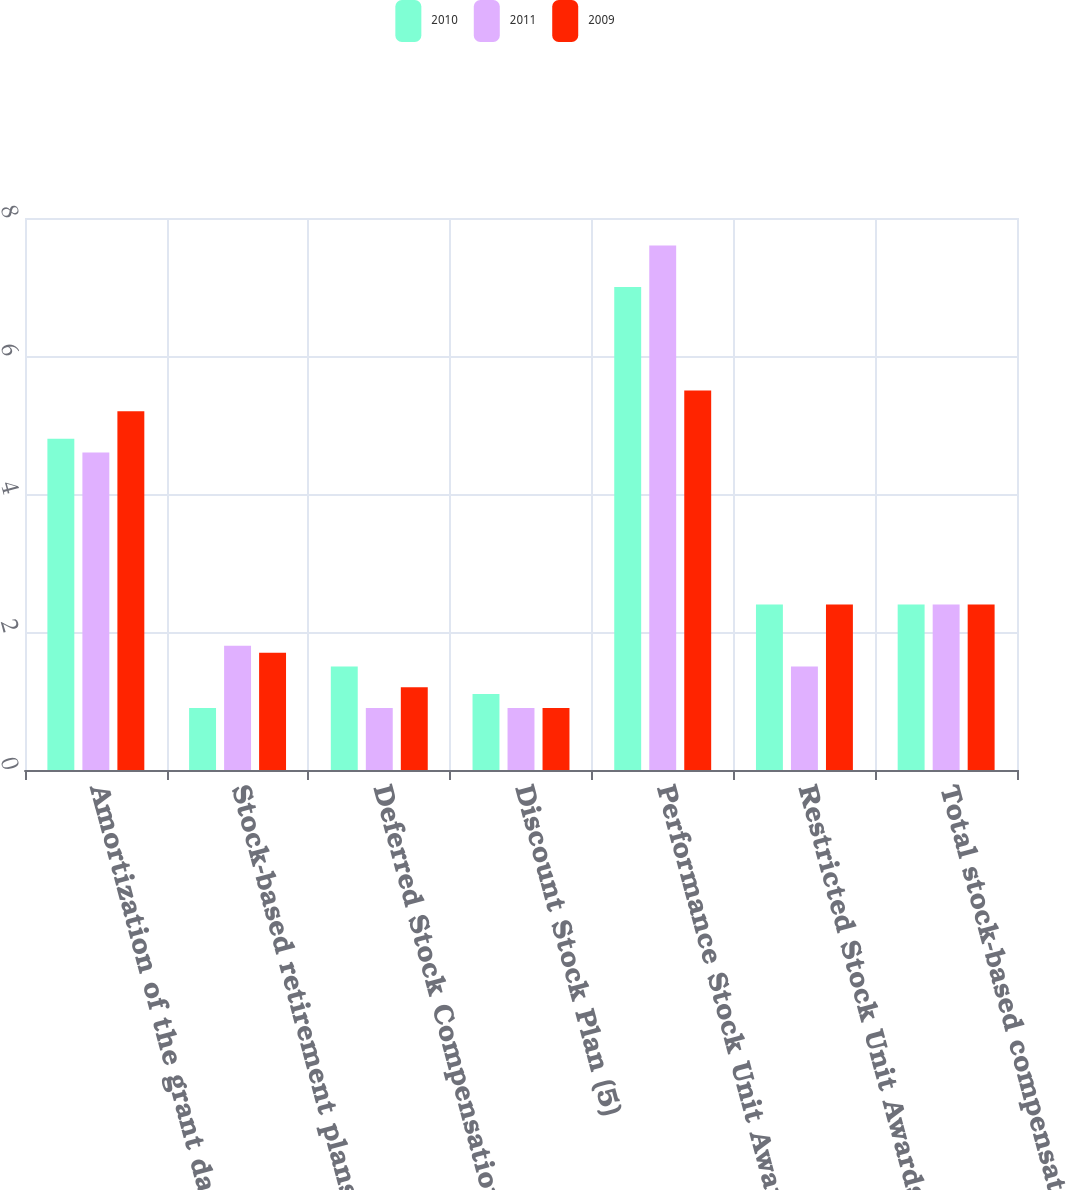<chart> <loc_0><loc_0><loc_500><loc_500><stacked_bar_chart><ecel><fcel>Amortization of the grant date<fcel>Stock-based retirement plans<fcel>Deferred Stock Compensation<fcel>Discount Stock Plan (5)<fcel>Performance Stock Unit Awards<fcel>Restricted Stock Unit Awards<fcel>Total stock-based compensation<nl><fcel>2010<fcel>4.8<fcel>0.9<fcel>1.5<fcel>1.1<fcel>7<fcel>2.4<fcel>2.4<nl><fcel>2011<fcel>4.6<fcel>1.8<fcel>0.9<fcel>0.9<fcel>7.6<fcel>1.5<fcel>2.4<nl><fcel>2009<fcel>5.2<fcel>1.7<fcel>1.2<fcel>0.9<fcel>5.5<fcel>2.4<fcel>2.4<nl></chart> 